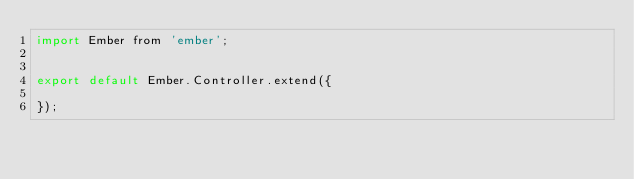<code> <loc_0><loc_0><loc_500><loc_500><_JavaScript_>import Ember from 'ember';


export default Ember.Controller.extend({

});
</code> 